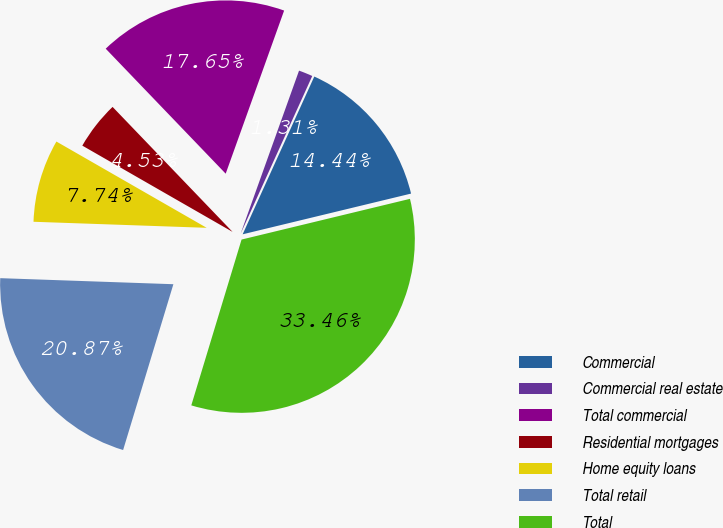<chart> <loc_0><loc_0><loc_500><loc_500><pie_chart><fcel>Commercial<fcel>Commercial real estate<fcel>Total commercial<fcel>Residential mortgages<fcel>Home equity loans<fcel>Total retail<fcel>Total<nl><fcel>14.44%<fcel>1.31%<fcel>17.65%<fcel>4.53%<fcel>7.74%<fcel>20.87%<fcel>33.46%<nl></chart> 